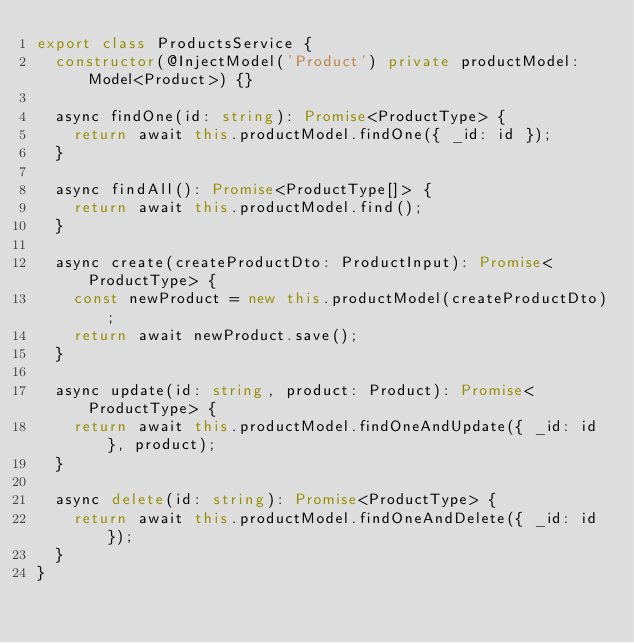<code> <loc_0><loc_0><loc_500><loc_500><_TypeScript_>export class ProductsService {
  constructor(@InjectModel('Product') private productModel: Model<Product>) {}

  async findOne(id: string): Promise<ProductType> {
    return await this.productModel.findOne({ _id: id });
  }

  async findAll(): Promise<ProductType[]> {
    return await this.productModel.find();
  }

  async create(createProductDto: ProductInput): Promise<ProductType> {
    const newProduct = new this.productModel(createProductDto);
    return await newProduct.save();
  }

  async update(id: string, product: Product): Promise<ProductType> {
    return await this.productModel.findOneAndUpdate({ _id: id }, product);
  }

  async delete(id: string): Promise<ProductType> {
    return await this.productModel.findOneAndDelete({ _id: id });
  }
}
</code> 